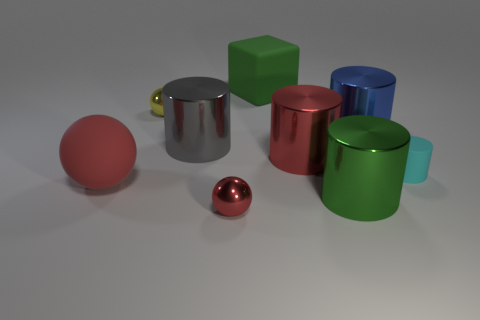Subtract all gray cylinders. How many cylinders are left? 4 Subtract all green cylinders. How many cylinders are left? 4 Subtract all purple cylinders. Subtract all cyan blocks. How many cylinders are left? 5 Add 1 gray cylinders. How many objects exist? 10 Subtract all cubes. How many objects are left? 8 Add 1 metallic balls. How many metallic balls are left? 3 Add 1 brown metal blocks. How many brown metal blocks exist? 1 Subtract 0 blue balls. How many objects are left? 9 Subtract all cyan matte things. Subtract all tiny balls. How many objects are left? 6 